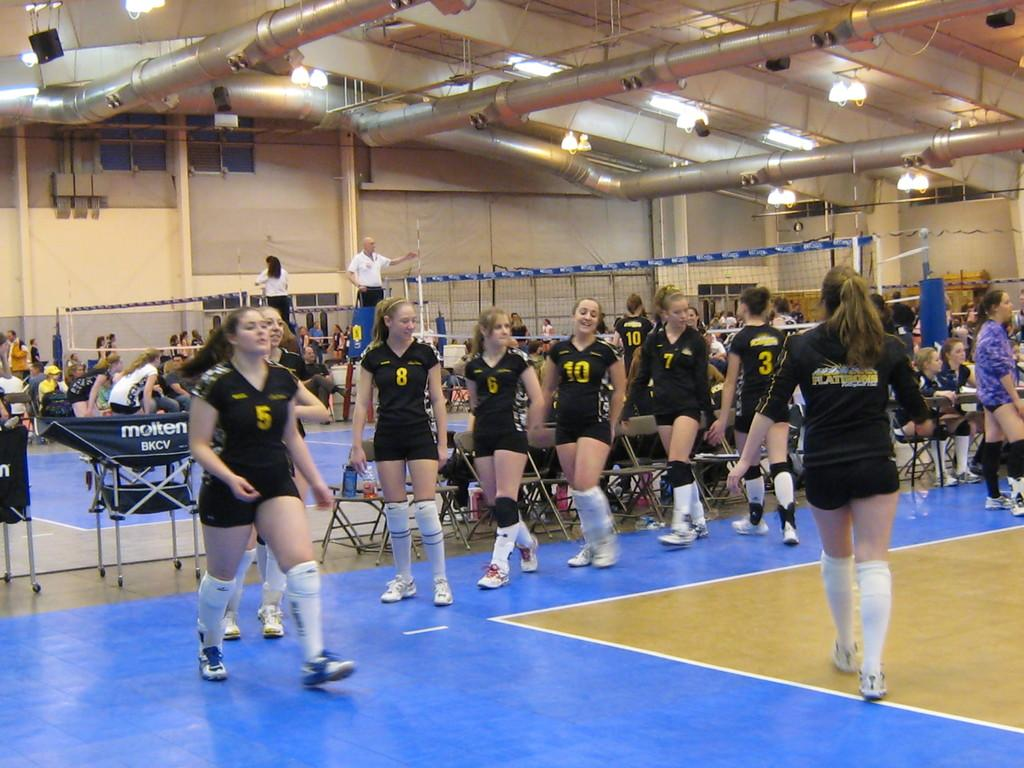Provide a one-sentence caption for the provided image. Several young females on the Flattrons team are in a gym. 